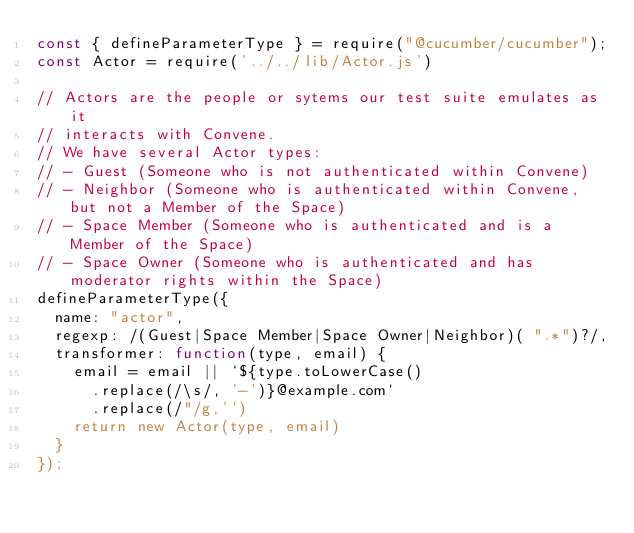Convert code to text. <code><loc_0><loc_0><loc_500><loc_500><_JavaScript_>const { defineParameterType } = require("@cucumber/cucumber");
const Actor = require('../../lib/Actor.js')

// Actors are the people or sytems our test suite emulates as it
// interacts with Convene.
// We have several Actor types:
// - Guest (Someone who is not authenticated within Convene)
// - Neighbor (Someone who is authenticated within Convene, but not a Member of the Space)
// - Space Member (Someone who is authenticated and is a Member of the Space)
// - Space Owner (Someone who is authenticated and has moderator rights within the Space)
defineParameterType({
  name: "actor",
  regexp: /(Guest|Space Member|Space Owner|Neighbor)( ".*")?/,
  transformer: function(type, email) {
    email = email || `${type.toLowerCase()
      .replace(/\s/, '-')}@example.com`
      .replace(/"/g,'')
    return new Actor(type, email)
  }
});</code> 